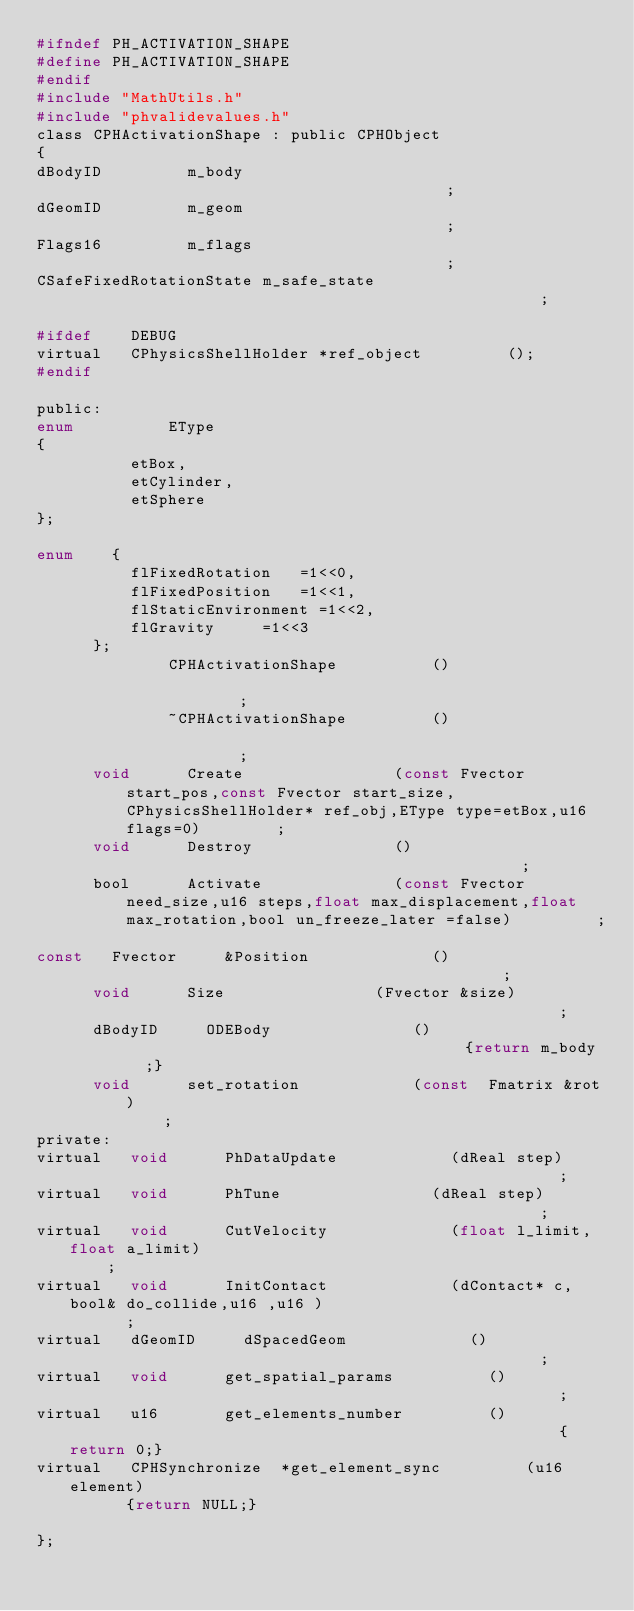Convert code to text. <code><loc_0><loc_0><loc_500><loc_500><_C_>#ifndef PH_ACTIVATION_SHAPE
#define PH_ACTIVATION_SHAPE
#endif
#include "MathUtils.h"
#include "phvalidevalues.h"
class CPHActivationShape : public CPHObject
{
dBodyID					m_body																																							;
dGeomID					m_geom																																							;
Flags16					m_flags																																							;
CSafeFixedRotationState m_safe_state																																					;			

#ifdef		DEBUG
virtual		CPhysicsShellHolder	*ref_object					();
#endif

public:
enum					EType
{
					etBox,
					etCylinder,
					etSphere
};

enum		{
					flFixedRotation		=1<<0,
					flFixedPosition		=1<<1,
					flStaticEnvironment	=1<<2,
					flGravity			=1<<3
			};
							CPHActivationShape					()																															;
							~CPHActivationShape					()																															;
			void			Create								(const Fvector start_pos,const Fvector start_size,CPhysicsShellHolder* ref_obj,EType type=etBox,u16	flags=0)				;
			void			Destroy								()																															;
			bool			Activate							(const Fvector need_size,u16 steps,float max_displacement,float max_rotation,bool	un_freeze_later	=false)					;															
const		Fvector			&Position							()																															;
			void			Size								(Fvector &size)																												;
			dBodyID			ODEBody								()																											{return m_body	;}
			void			set_rotation						(const	Fmatrix	&rot)																											;
private:
virtual		void			PhDataUpdate						(dReal step)																												;
virtual		void			PhTune								(dReal step)																												;
virtual		void			CutVelocity							(float l_limit,float a_limit)																								;						
virtual		void			InitContact							(dContact* c,bool& do_collide,u16 ,u16 )																		;
virtual		dGeomID			dSpacedGeom							()																															;
virtual		void			get_spatial_params					()																															;
virtual		u16				get_elements_number					()																															{return 0;}
virtual		CPHSynchronize	*get_element_sync					(u16 element)																												{return NULL;}		

};</code> 